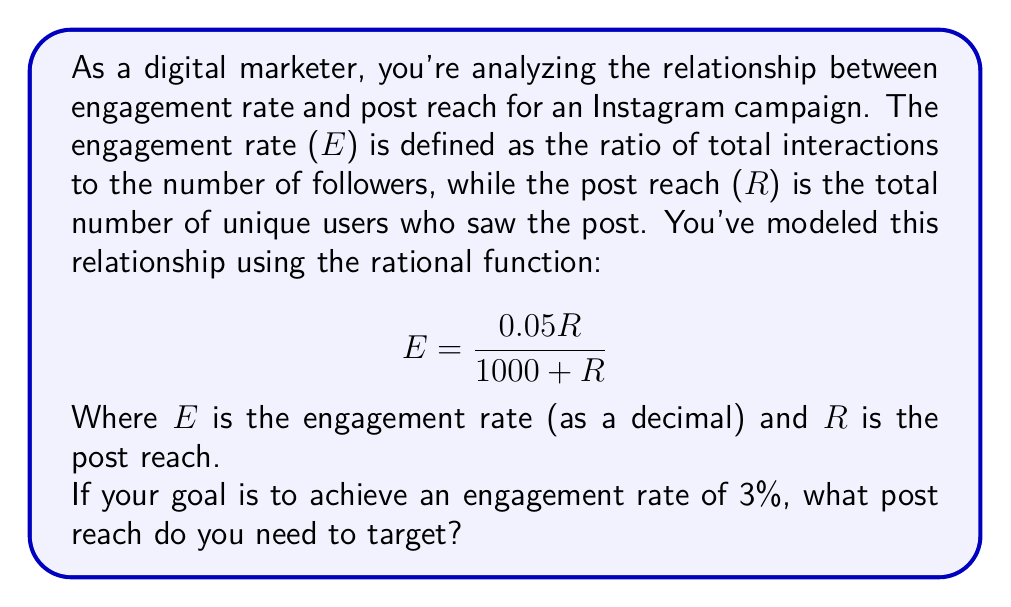Teach me how to tackle this problem. Let's approach this step-by-step:

1) We're given the rational function: $$E = \frac{0.05R}{1000 + R}$$

2) We want to find R when E = 0.03 (3% as a decimal)

3) Let's substitute E with 0.03:

   $$0.03 = \frac{0.05R}{1000 + R}$$

4) Now, let's solve this equation for R:

   Multiply both sides by (1000 + R):
   $$0.03(1000 + R) = 0.05R$$

5) Expand the left side:
   $$30 + 0.03R = 0.05R$$

6) Subtract 0.03R from both sides:
   $$30 = 0.02R$$

7) Divide both sides by 0.02:
   $$R = \frac{30}{0.02} = 1500$$

Therefore, to achieve an engagement rate of 3%, you need to target a post reach of 1500 unique users.
Answer: 1500 